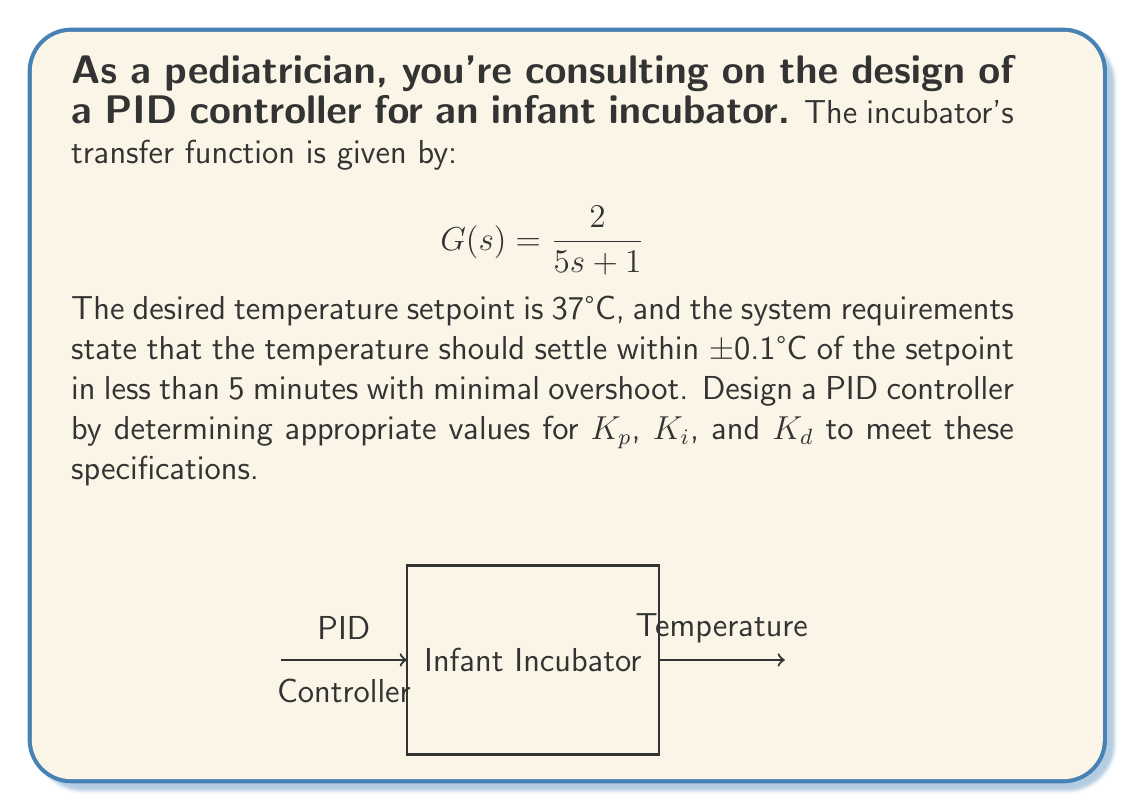Show me your answer to this math problem. To design a PID controller for the infant incubator, we'll follow these steps:

1) The PID controller transfer function is:
   $$C(s) = K_p + \frac{K_i}{s} + K_d s$$

2) The closed-loop transfer function becomes:
   $$T(s) = \frac{C(s)G(s)}{1 + C(s)G(s)} = \frac{(2K_p + 2K_i s^{-1} + 2K_d s)(5s + 1)^{-1}}{1 + (2K_p + 2K_i s^{-1} + 2K_d s)(5s + 1)^{-1}}$$

3) For minimal overshoot and quick settling time, we aim for a damping ratio ζ ≈ 0.7 and natural frequency ωn ≈ 1 rad/s.

4) Comparing the denominator of T(s) to the standard form s^2 + 2ζωn s + ωn^2, we get:
   $$s^2 + (0.2 + 0.4K_d)s + 0.4K_p = s^2 + 2(0.7)(1)s + 1^2$$

5) Equating coefficients:
   0.2 + 0.4K_d = 1.4
   0.4K_p = 1

6) Solving these equations:
   K_d = 3
   K_p = 2.5

7) To eliminate steady-state error, we add integral action:
   K_i = 0.1 (a small value to avoid instability)

8) Fine-tune these values through simulation to ensure the 5-minute settling time and ±0.1°C accuracy are met.
Answer: K_p = 2.5, K_i = 0.1, K_d = 3 